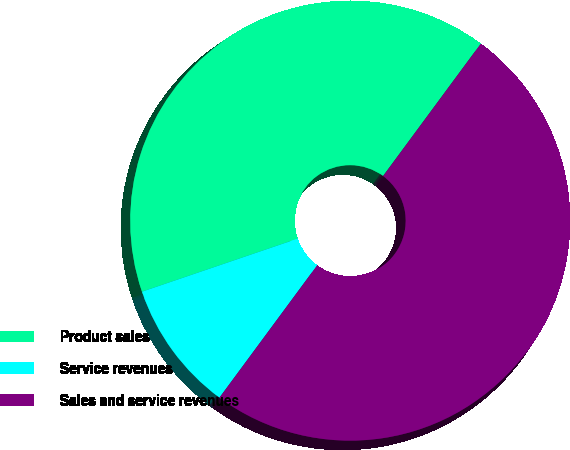Convert chart to OTSL. <chart><loc_0><loc_0><loc_500><loc_500><pie_chart><fcel>Product sales<fcel>Service revenues<fcel>Sales and service revenues<nl><fcel>40.35%<fcel>9.65%<fcel>50.0%<nl></chart> 